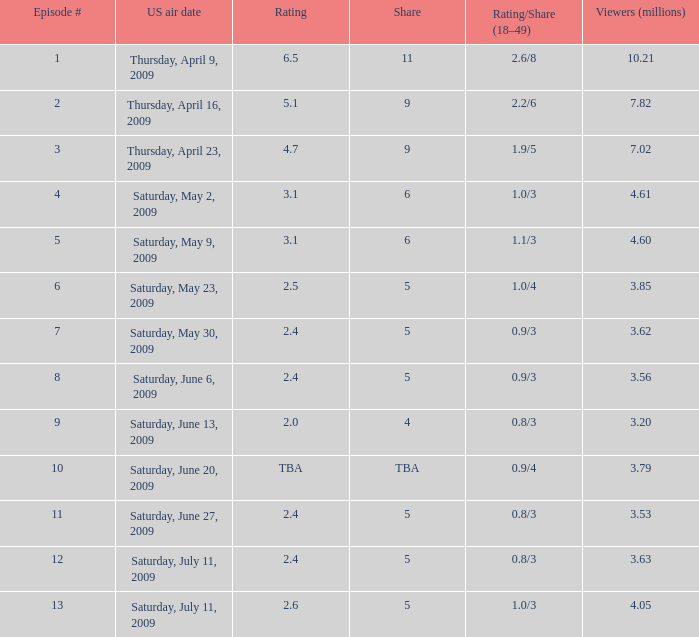What is the lowest numbered episode that had a rating/share of 0.9/4 and more than 3.79 million viewers? None. 